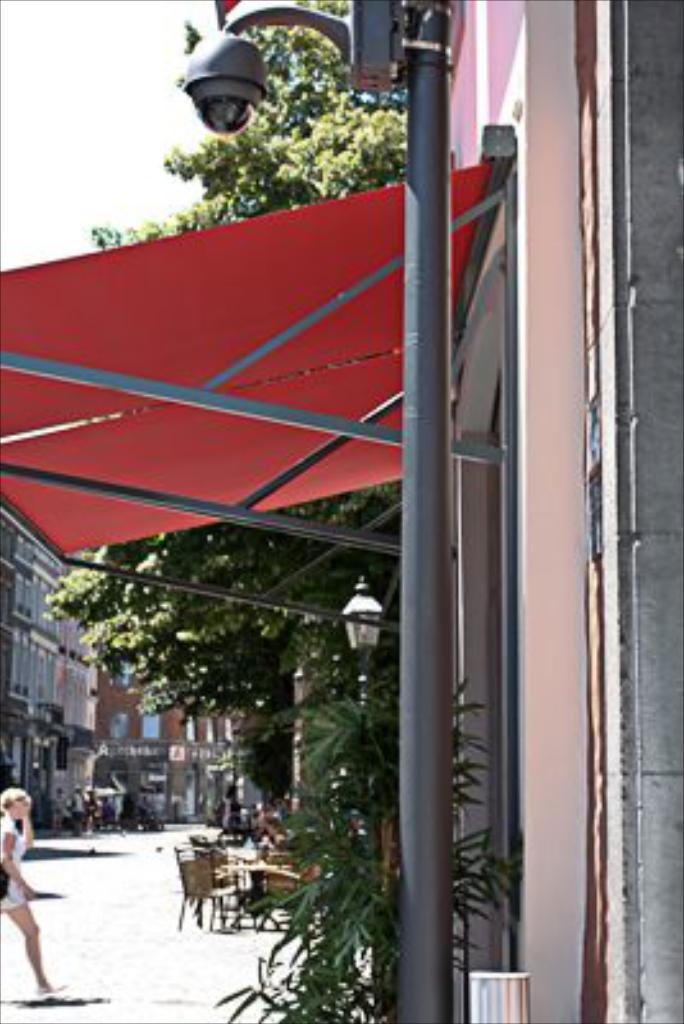Describe this image in one or two sentences. In this image I see a woman over here and she is wearing white dress and I see a pole over here and I see the path. In the background I see the buildings, trees, chairs and I see a street light over here and I see the sky. 